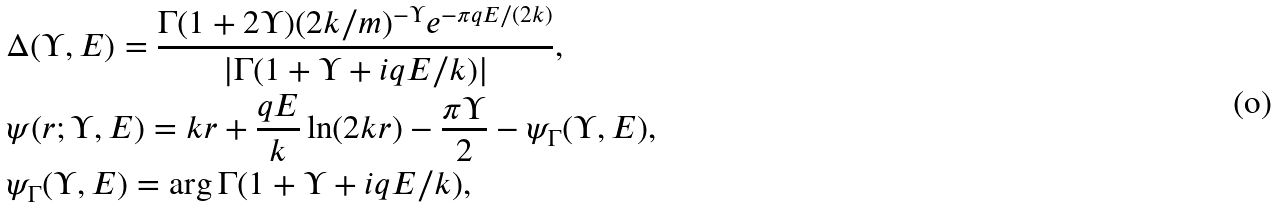<formula> <loc_0><loc_0><loc_500><loc_500>& \Delta ( \Upsilon , E ) = \frac { \Gamma ( 1 + 2 \Upsilon ) ( 2 k / m ) ^ { - \Upsilon } e ^ { - \pi q E / ( 2 k ) } } { | \Gamma ( 1 + \Upsilon + i q E / k ) | } , \\ & \psi ( r ; \Upsilon , E ) = k r + \frac { q E } { k } \ln ( 2 k r ) - \frac { \pi \Upsilon } { 2 } - \psi _ { \Gamma } ( \Upsilon , E ) , \\ & \psi _ { \Gamma } ( \Upsilon , E ) = \arg { \Gamma ( 1 + \Upsilon + i q E / k ) } ,</formula> 